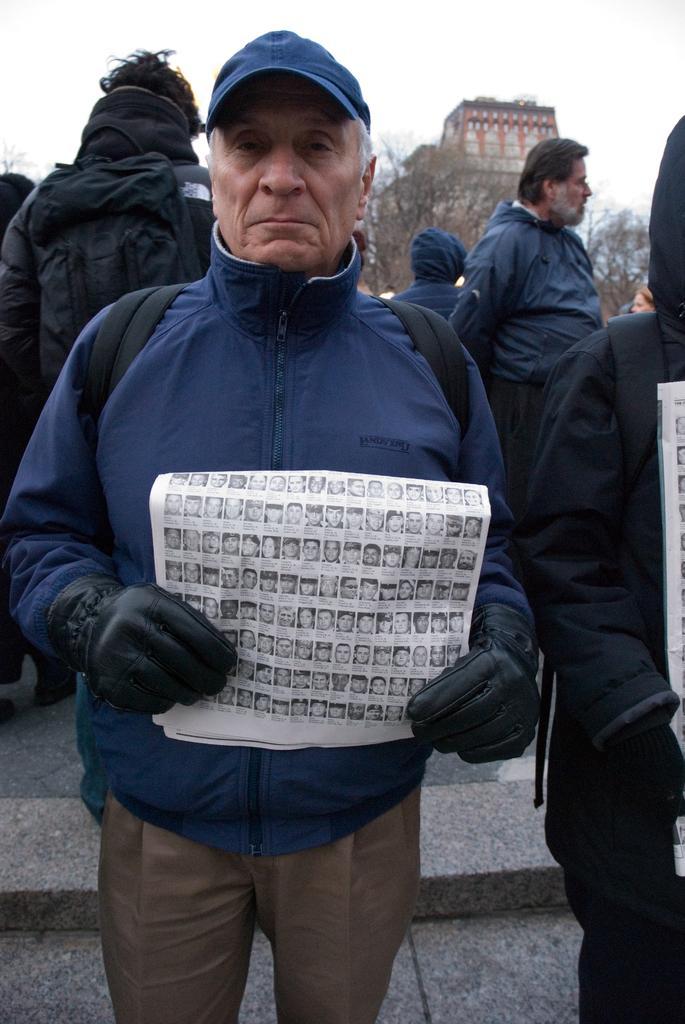How would you summarize this image in a sentence or two? In the foreground of the picture there is a person wearing a jacket and holding a paper. On the right there is another person standing and holding paper. In the background there are people, trees and building. Sky is cloudy. 